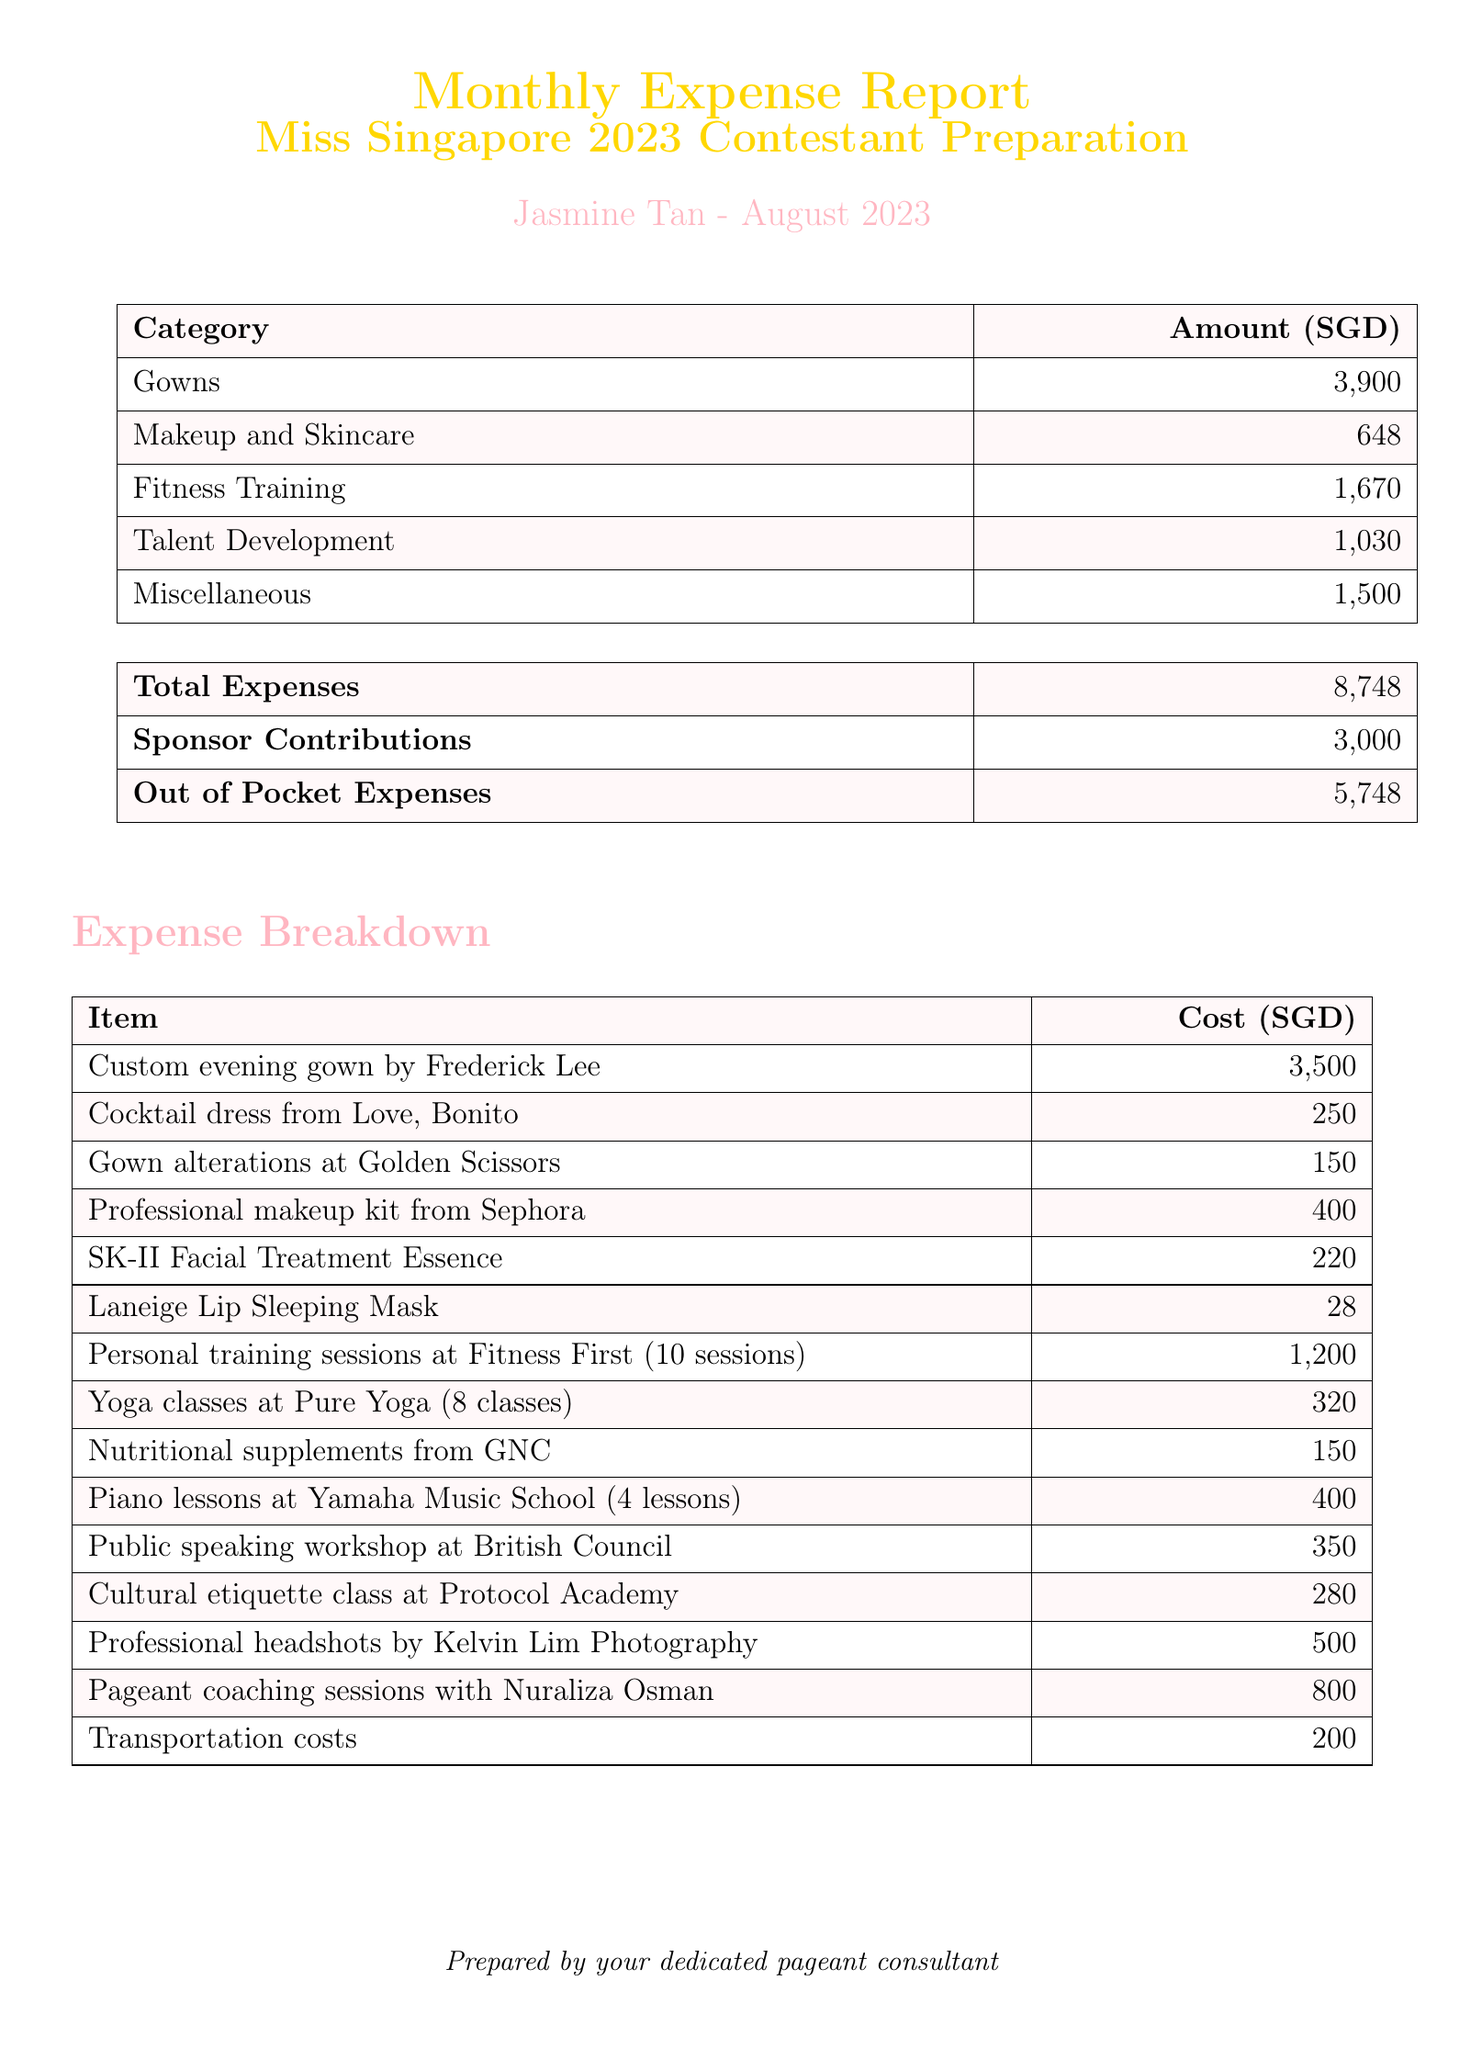What is the total expense for August 2023? The total expense is listed at the end of the report and is the sum of all expenses in different categories.
Answer: 8748 Who is the contestant mentioned in the report? The contestant's name is provided at the top of the report.
Answer: Jasmine Tan How much was spent on gowns? The amount spent on gowns is shown in the category breakdown of expenses.
Answer: 3900 What is the cost of the custom evening gown? The specific cost of the custom evening gown is detailed in the expense breakdown.
Answer: 3500 How many personal training sessions were included in the fitness training expenses? The report specifies the number of sessions included in the costs for fitness training.
Answer: 10 What was the total cost for talent development? The total cost for talent development is summarized in the expense categories section of the report.
Answer: 1030 How much did the contestant pay out of pocket? The out of pocket expenses are listed in the summary table of the report.
Answer: 5748 What category has the highest expense? The highest expense category can be identified by comparing the listed amounts for each category.
Answer: Gowns What is the significance of the sponsor contributions? The sponsor contributions are outlined in the summary and indicate financial support for the contestant.
Answer: 3000 